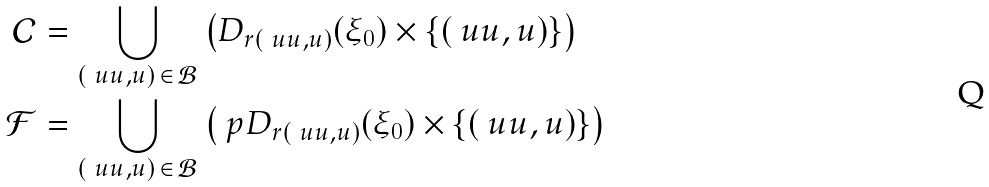Convert formula to latex. <formula><loc_0><loc_0><loc_500><loc_500>\mathcal { C } & = \bigcup _ { ( \ u { u } , u ) \, \in \, \mathcal { B } } \left ( D _ { r ( \ u { u } , u ) } ( \xi _ { 0 } ) \times \{ ( \ u { u } , u ) \} \right ) \\ \mathcal { F } & = \bigcup _ { ( \ u { u } , u ) \, \in \, \mathcal { B } } \left ( \ p D _ { r ( \ u { u } , u ) } ( \xi _ { 0 } ) \times \{ ( \ u { u } , u ) \} \right )</formula> 